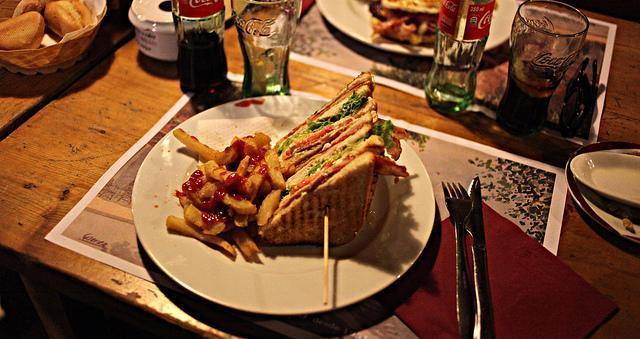How many bottles are in the photo?
Give a very brief answer. 2. How many cups can you see?
Give a very brief answer. 2. 